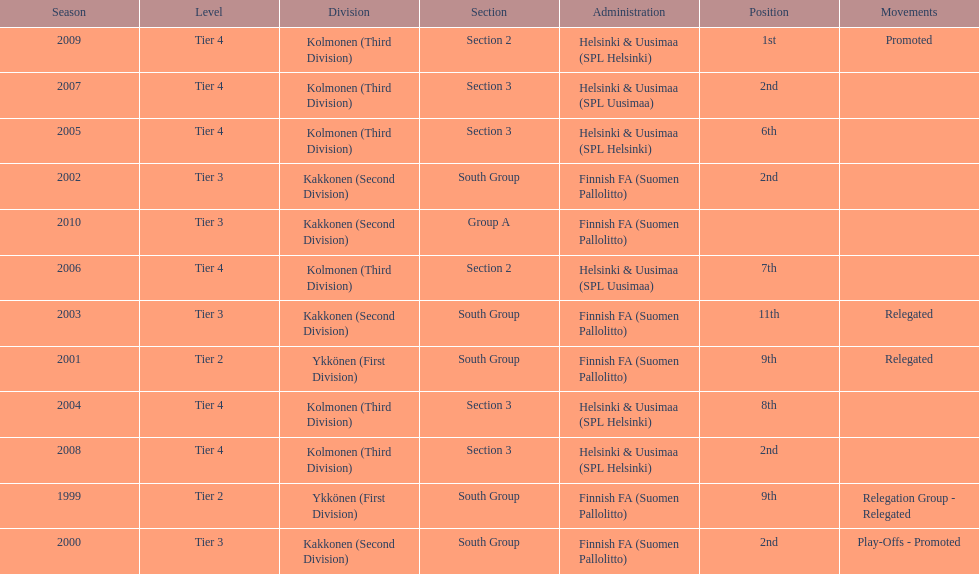How many 2nd positions were there? 4. Parse the table in full. {'header': ['Season', 'Level', 'Division', 'Section', 'Administration', 'Position', 'Movements'], 'rows': [['2009', 'Tier 4', 'Kolmonen (Third Division)', 'Section 2', 'Helsinki & Uusimaa (SPL Helsinki)', '1st', 'Promoted'], ['2007', 'Tier 4', 'Kolmonen (Third Division)', 'Section 3', 'Helsinki & Uusimaa (SPL Uusimaa)', '2nd', ''], ['2005', 'Tier 4', 'Kolmonen (Third Division)', 'Section 3', 'Helsinki & Uusimaa (SPL Helsinki)', '6th', ''], ['2002', 'Tier 3', 'Kakkonen (Second Division)', 'South Group', 'Finnish FA (Suomen Pallolitto)', '2nd', ''], ['2010', 'Tier 3', 'Kakkonen (Second Division)', 'Group A', 'Finnish FA (Suomen Pallolitto)', '', ''], ['2006', 'Tier 4', 'Kolmonen (Third Division)', 'Section 2', 'Helsinki & Uusimaa (SPL Uusimaa)', '7th', ''], ['2003', 'Tier 3', 'Kakkonen (Second Division)', 'South Group', 'Finnish FA (Suomen Pallolitto)', '11th', 'Relegated'], ['2001', 'Tier 2', 'Ykkönen (First Division)', 'South Group', 'Finnish FA (Suomen Pallolitto)', '9th', 'Relegated'], ['2004', 'Tier 4', 'Kolmonen (Third Division)', 'Section 3', 'Helsinki & Uusimaa (SPL Helsinki)', '8th', ''], ['2008', 'Tier 4', 'Kolmonen (Third Division)', 'Section 3', 'Helsinki & Uusimaa (SPL Helsinki)', '2nd', ''], ['1999', 'Tier 2', 'Ykkönen (First Division)', 'South Group', 'Finnish FA (Suomen Pallolitto)', '9th', 'Relegation Group - Relegated'], ['2000', 'Tier 3', 'Kakkonen (Second Division)', 'South Group', 'Finnish FA (Suomen Pallolitto)', '2nd', 'Play-Offs - Promoted']]} 